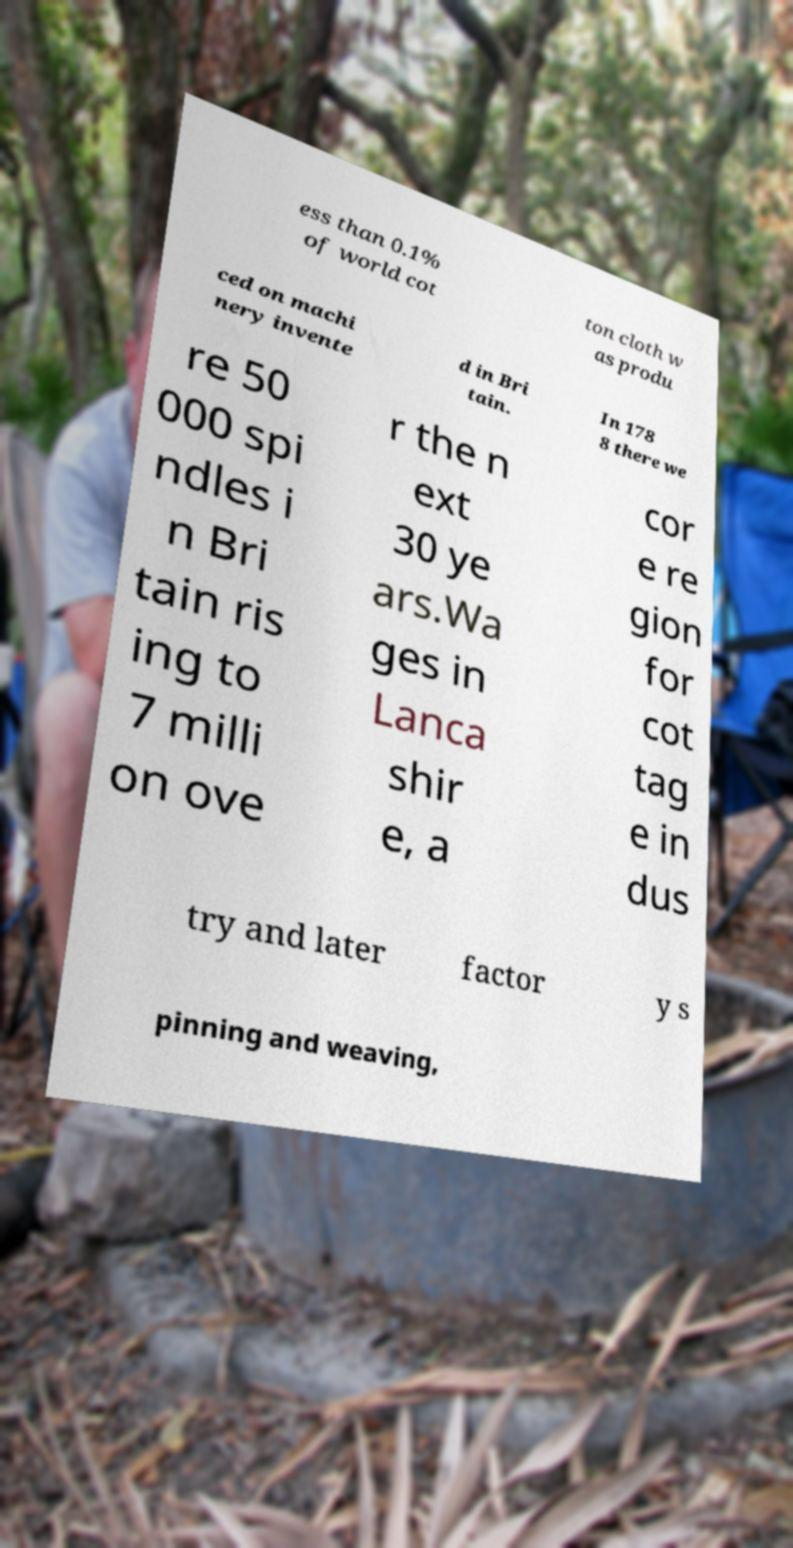Can you read and provide the text displayed in the image?This photo seems to have some interesting text. Can you extract and type it out for me? ess than 0.1% of world cot ton cloth w as produ ced on machi nery invente d in Bri tain. In 178 8 there we re 50 000 spi ndles i n Bri tain ris ing to 7 milli on ove r the n ext 30 ye ars.Wa ges in Lanca shir e, a cor e re gion for cot tag e in dus try and later factor y s pinning and weaving, 